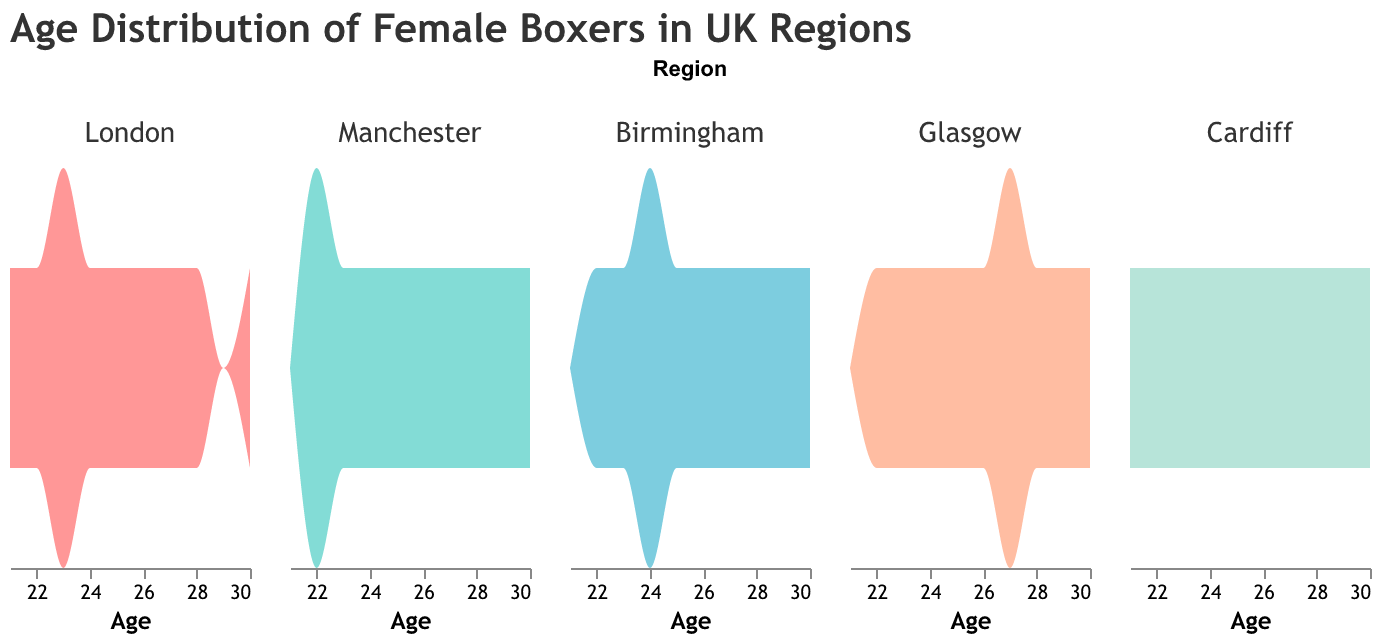What's the title of the figure? The title is located at the top of the figure, often displayed in a larger font size and different color. In this case, it is "Age Distribution of Female Boxers in UK Regions".
Answer: Age Distribution of Female Boxers in UK Regions List the regions included in the figure. The regions are mentioned in the facet column's sort order. Here, the regions listed are London, Manchester, Birmingham, Glasgow, and Cardiff.
Answer: London, Manchester, Birmingham, Glasgow, Cardiff What is the color used for representing the London region? By looking at the color legend of the figure, we can identify the color used for representing the London region, which is typically displayed as a pinkish-red shade.
Answer: Pinkish-red Which age group has the highest density of boxers in Manchester? To determine this, we look at the peak of the density plot for the Manchester region. The highest peak on the x-axis, representing age, will show the age group with the highest density.
Answer: 22 and 29 Compare the age distributions between Glasgow and Cardiff. Which region has a more evenly spread age distribution? By comparing the density plots, Glasgow shows multiple peaks (22, 24, 27), indicating an even spread. Cardiff has a less even spread with noticeable peaks at 22 and 30.
Answer: Glasgow For which region is the age 30 notably present? By analyzing the density plot, we can observe the regions where the peak shifts towards the age of 30. Both London, Manchester, Birmingham, Glasgow, and Cardiff show notable density at age 30.
Answer: London, Manchester, Birmingham, Glasgow, Cardiff Which region has the youngest age recorded and what is that age? We look at the lowest age represented in each region’s density plot. Cardiff has an age of 21, which is the youngest.
Answer: Cardiff, 21 Which two regions have the closest age distributions? By visually comparing the density plots, Birmingham and Glasgow show very similar patterns in age distribution with peaks around ages 22-30.
Answer: Birmingham and Glasgow 